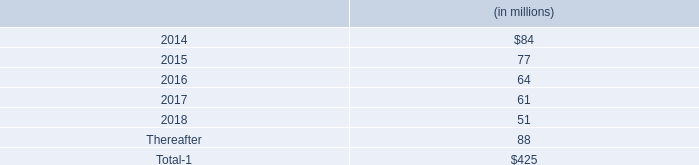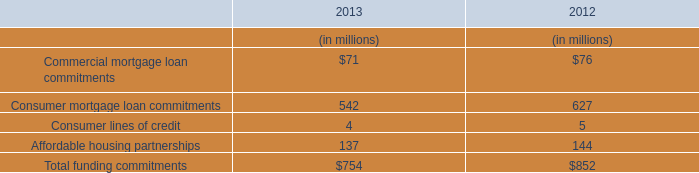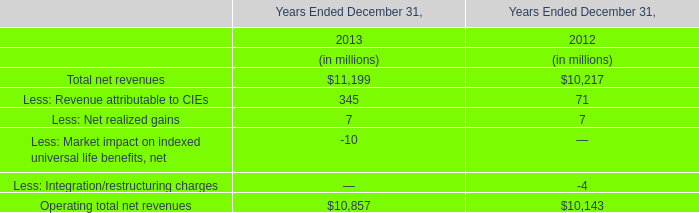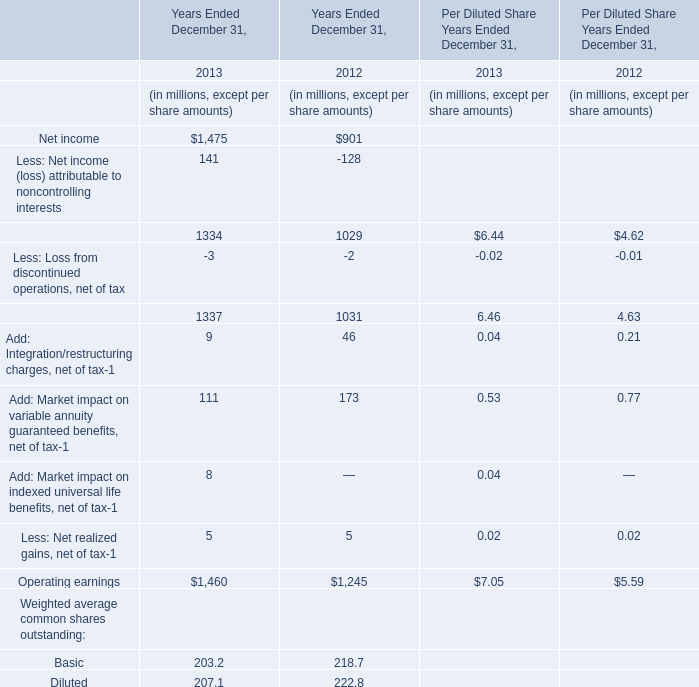If Net income develops with the same increasing rate in 2013, what will it reach in 2014? (in million) 
Computations: (1475 * (1 + ((1475 - 901) / 901)))
Answer: 2414.67814. 